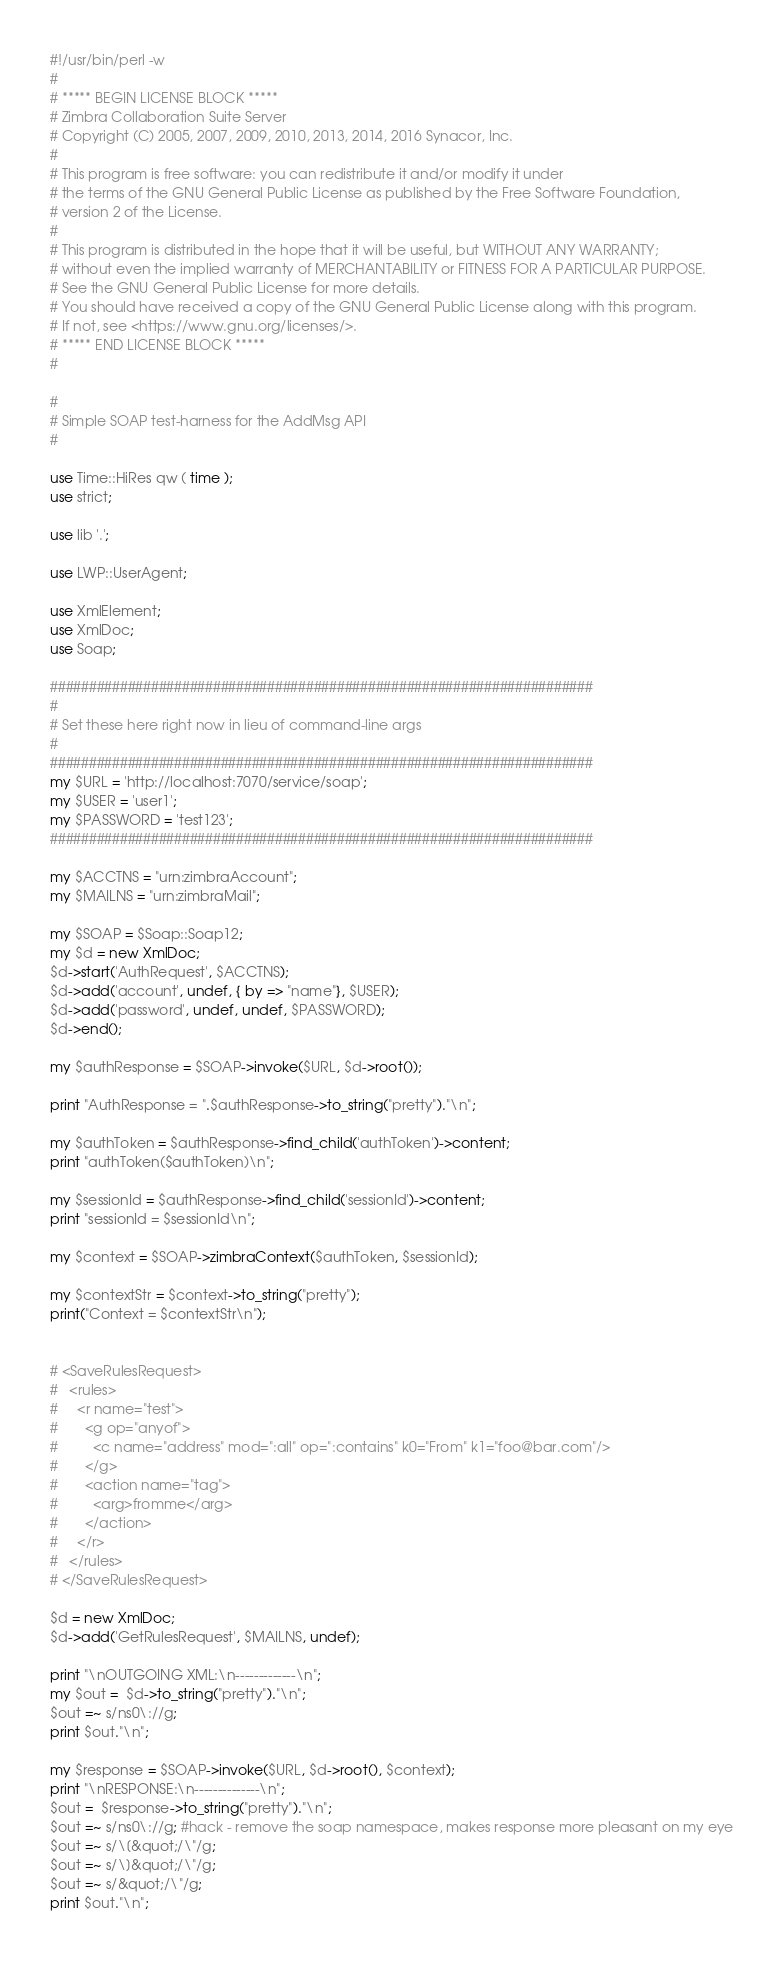Convert code to text. <code><loc_0><loc_0><loc_500><loc_500><_Perl_>#!/usr/bin/perl -w
# 
# ***** BEGIN LICENSE BLOCK *****
# Zimbra Collaboration Suite Server
# Copyright (C) 2005, 2007, 2009, 2010, 2013, 2014, 2016 Synacor, Inc.
#
# This program is free software: you can redistribute it and/or modify it under
# the terms of the GNU General Public License as published by the Free Software Foundation,
# version 2 of the License.
#
# This program is distributed in the hope that it will be useful, but WITHOUT ANY WARRANTY;
# without even the implied warranty of MERCHANTABILITY or FITNESS FOR A PARTICULAR PURPOSE.
# See the GNU General Public License for more details.
# You should have received a copy of the GNU General Public License along with this program.
# If not, see <https://www.gnu.org/licenses/>.
# ***** END LICENSE BLOCK *****
# 

#
# Simple SOAP test-harness for the AddMsg API
#

use Time::HiRes qw ( time );
use strict;

use lib '.';

use LWP::UserAgent;

use XmlElement;
use XmlDoc;
use Soap;

######################################################################
#
# Set these here right now in lieu of command-line args
#
######################################################################
my $URL = 'http://localhost:7070/service/soap';
my $USER = 'user1';
my $PASSWORD = 'test123';
######################################################################

my $ACCTNS = "urn:zimbraAccount";
my $MAILNS = "urn:zimbraMail";

my $SOAP = $Soap::Soap12;
my $d = new XmlDoc;
$d->start('AuthRequest', $ACCTNS);
$d->add('account', undef, { by => "name"}, $USER);
$d->add('password', undef, undef, $PASSWORD);
$d->end();

my $authResponse = $SOAP->invoke($URL, $d->root());

print "AuthResponse = ".$authResponse->to_string("pretty")."\n";

my $authToken = $authResponse->find_child('authToken')->content;
print "authToken($authToken)\n";

my $sessionId = $authResponse->find_child('sessionId')->content;
print "sessionId = $sessionId\n";

my $context = $SOAP->zimbraContext($authToken, $sessionId);

my $contextStr = $context->to_string("pretty");
print("Context = $contextStr\n");


# <SaveRulesRequest>
#   <rules>
#     <r name="test">
#       <g op="anyof">
#         <c name="address" mod=":all" op=":contains" k0="From" k1="foo@bar.com"/>
#       </g>
#       <action name="tag">
#         <arg>fromme</arg>
#       </action>   
#     </r>
#   </rules>
# </SaveRulesRequest>

$d = new XmlDoc;
$d->add('GetRulesRequest', $MAILNS, undef);

print "\nOUTGOING XML:\n-------------\n";
my $out =  $d->to_string("pretty")."\n";
$out =~ s/ns0\://g;
print $out."\n";

my $response = $SOAP->invoke($URL, $d->root(), $context);
print "\nRESPONSE:\n--------------\n";
$out =  $response->to_string("pretty")."\n";
$out =~ s/ns0\://g; #hack - remove the soap namespace, makes response more pleasant on my eye
$out =~ s/\[&quot;/\"/g;
$out =~ s/\]&quot;/\"/g;
$out =~ s/&quot;/\"/g;
print $out."\n";



</code> 